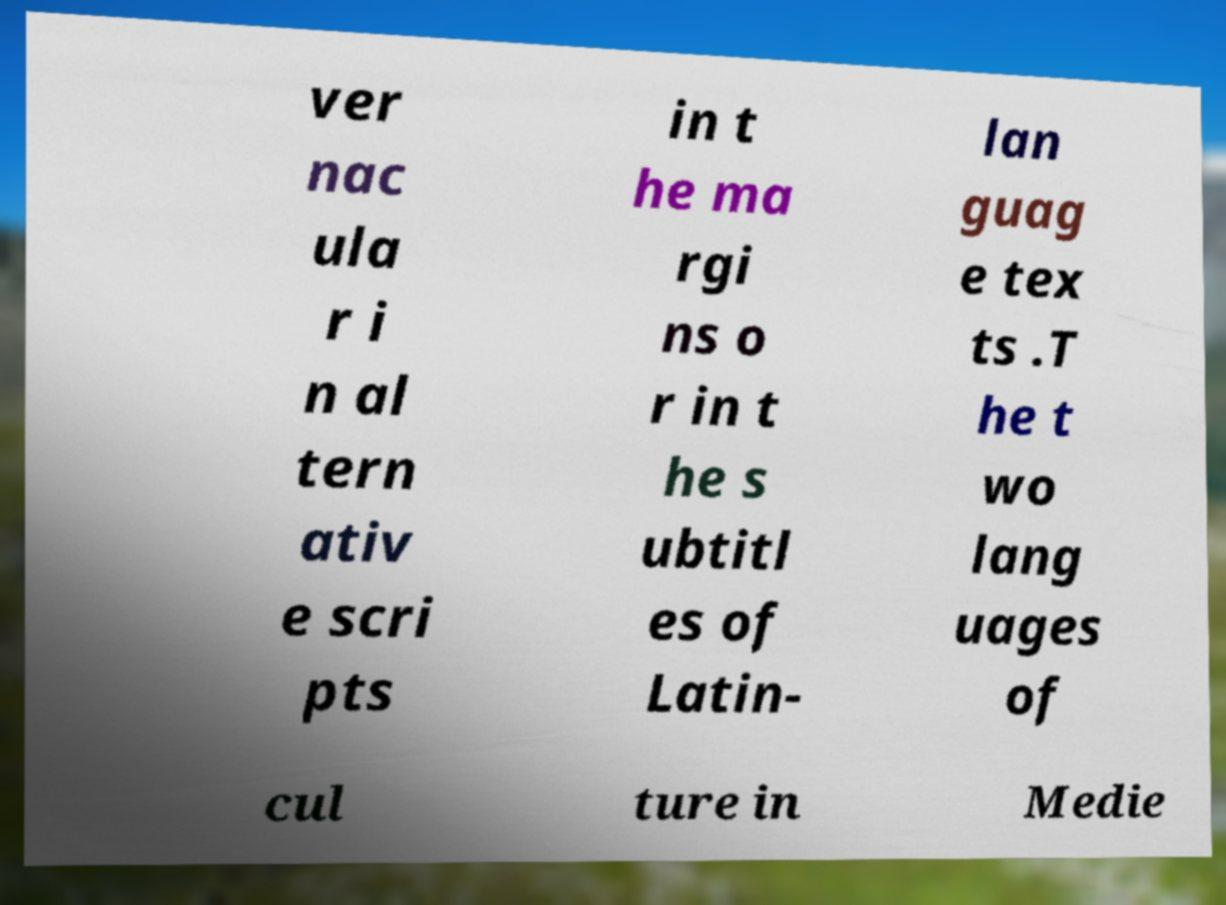Can you read and provide the text displayed in the image?This photo seems to have some interesting text. Can you extract and type it out for me? ver nac ula r i n al tern ativ e scri pts in t he ma rgi ns o r in t he s ubtitl es of Latin- lan guag e tex ts .T he t wo lang uages of cul ture in Medie 